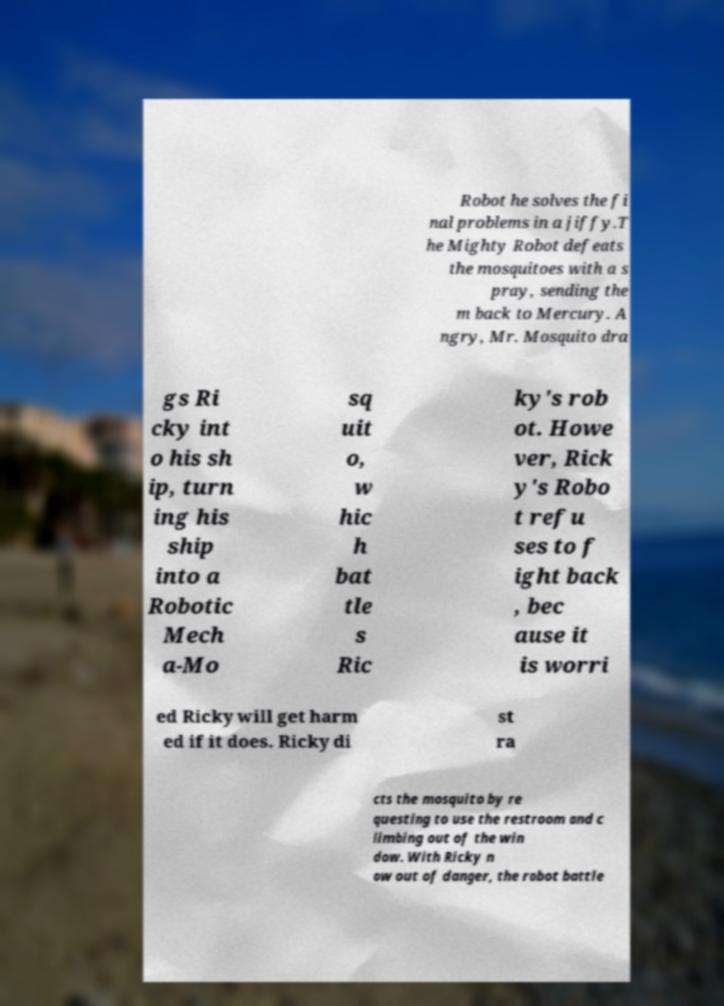What messages or text are displayed in this image? I need them in a readable, typed format. Robot he solves the fi nal problems in a jiffy.T he Mighty Robot defeats the mosquitoes with a s pray, sending the m back to Mercury. A ngry, Mr. Mosquito dra gs Ri cky int o his sh ip, turn ing his ship into a Robotic Mech a-Mo sq uit o, w hic h bat tle s Ric ky's rob ot. Howe ver, Rick y's Robo t refu ses to f ight back , bec ause it is worri ed Ricky will get harm ed if it does. Ricky di st ra cts the mosquito by re questing to use the restroom and c limbing out of the win dow. With Ricky n ow out of danger, the robot battle 